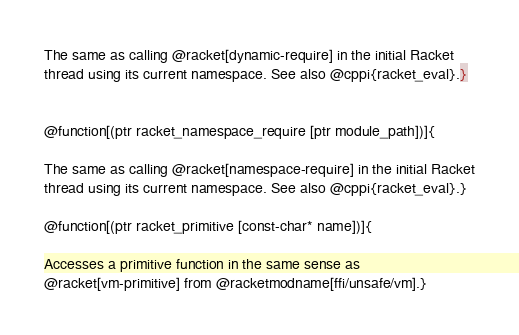Convert code to text. <code><loc_0><loc_0><loc_500><loc_500><_Racket_>
The same as calling @racket[dynamic-require] in the initial Racket
thread using its current namespace. See also @cppi{racket_eval}.}


@function[(ptr racket_namespace_require [ptr module_path])]{

The same as calling @racket[namespace-require] in the initial Racket
thread using its current namespace. See also @cppi{racket_eval}.}

@function[(ptr racket_primitive [const-char* name])]{

Accesses a primitive function in the same sense as
@racket[vm-primitive] from @racketmodname[ffi/unsafe/vm].}
</code> 